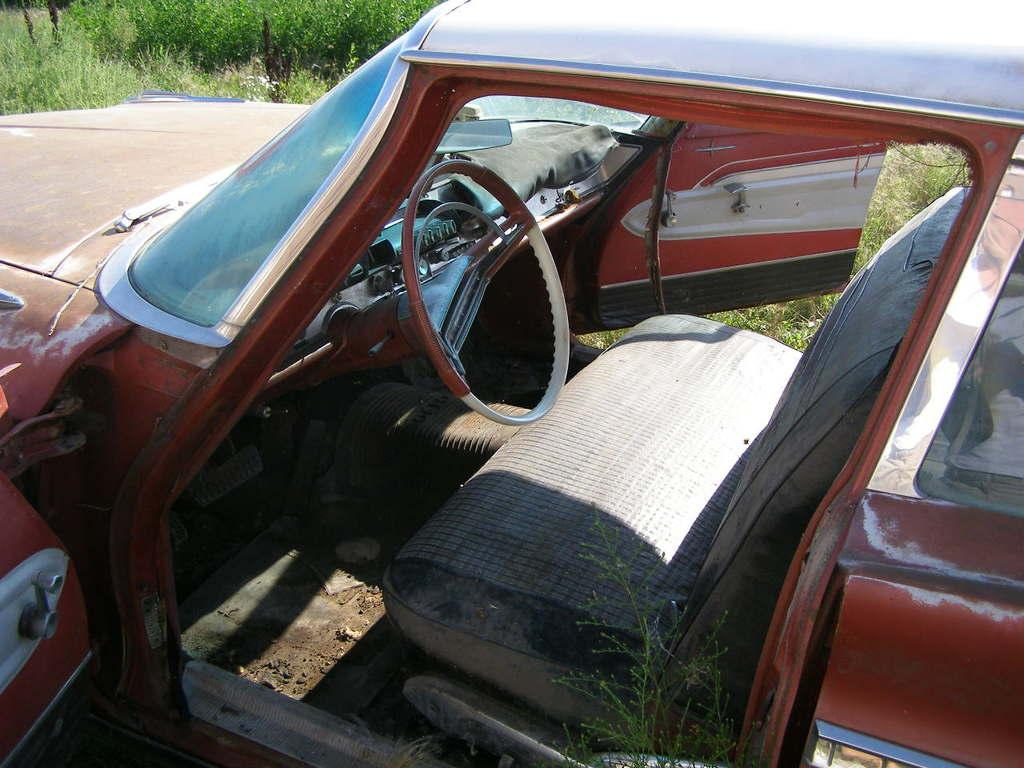What is the main subject in the center of the image? There is a vehicle in the center of the image. What can be seen in the background of the image? There are trees in the background of the image. How much profit does the coach earn in the image? There is no coach or mention of profit in the image; it features a vehicle and trees in the background. 